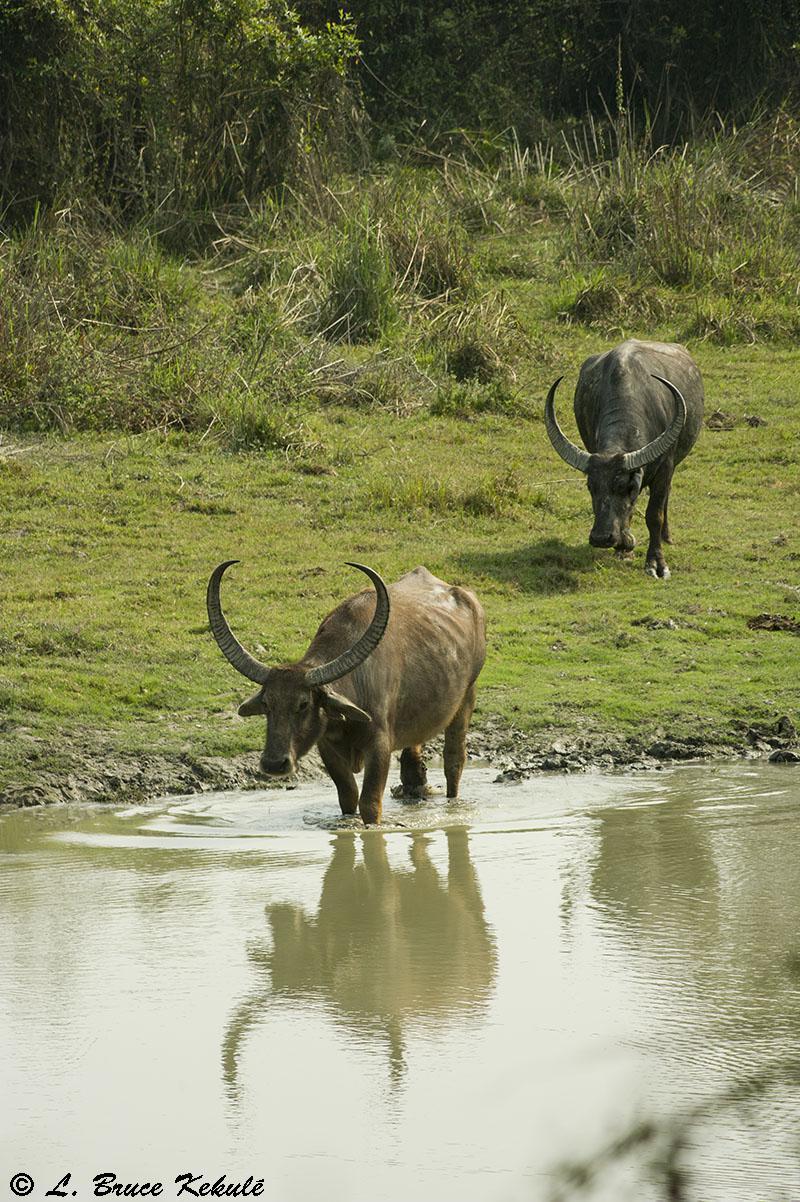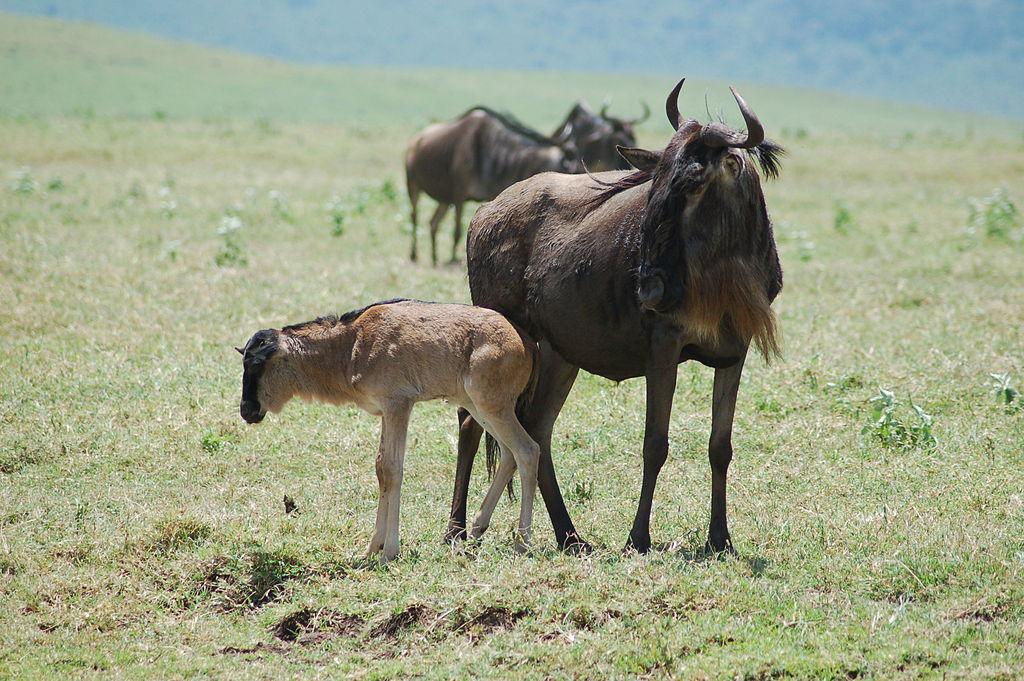The first image is the image on the left, the second image is the image on the right. Examine the images to the left and right. Is the description "Both images have only one dark bull each." accurate? Answer yes or no. No. The first image is the image on the left, the second image is the image on the right. Evaluate the accuracy of this statement regarding the images: "There is only one bull facing left in the left image.". Is it true? Answer yes or no. No. 